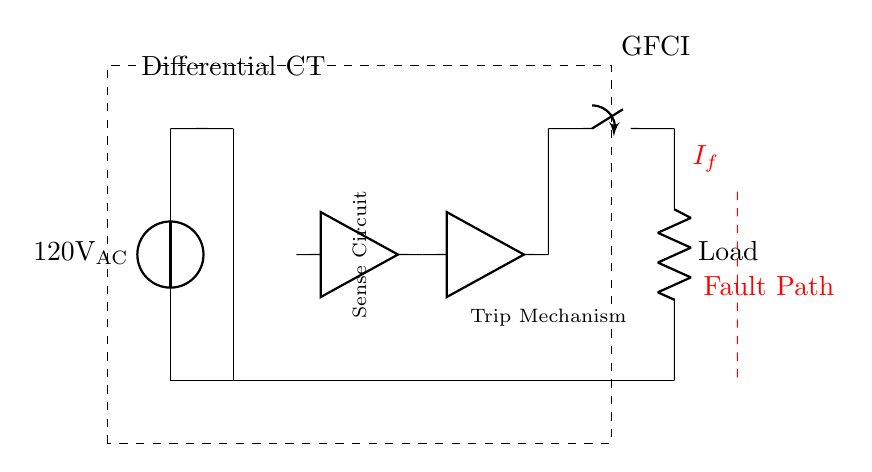What is the voltage of this circuit? The voltage is 120 volts AC, which is specified at the voltage source in the diagram.
Answer: 120 volts AC What component is represented by the dashed rectangle? The dashed rectangle signifies the GFCI block, indicating the area containing the ground fault circuit interrupter components.
Answer: GFCI block What does the red dashed line represent? The red dashed line signifies the fault path, showing the route taken by the ground fault current in case of a fault.
Answer: Fault Path Which component is responsible for sensing the current? The component that senses the current is labeled as the sense circuit, which monitors for any imbalance in the current.
Answer: Sense Circuit What is the purpose of the trip mechanism in this circuit? The trip mechanism automatically opens the circuit when a ground fault is detected, thereby protecting users from electric shock.
Answer: Protection How many transformers are used in this GFCI circuit? There is one transformer core shown in the circuit, which is part of the differential current transformer used for sensing.
Answer: One transformer What is the load specified in the circuit? The load is indicated simply as "Load," representing the component that uses the electrical current from the power supply.
Answer: Load 